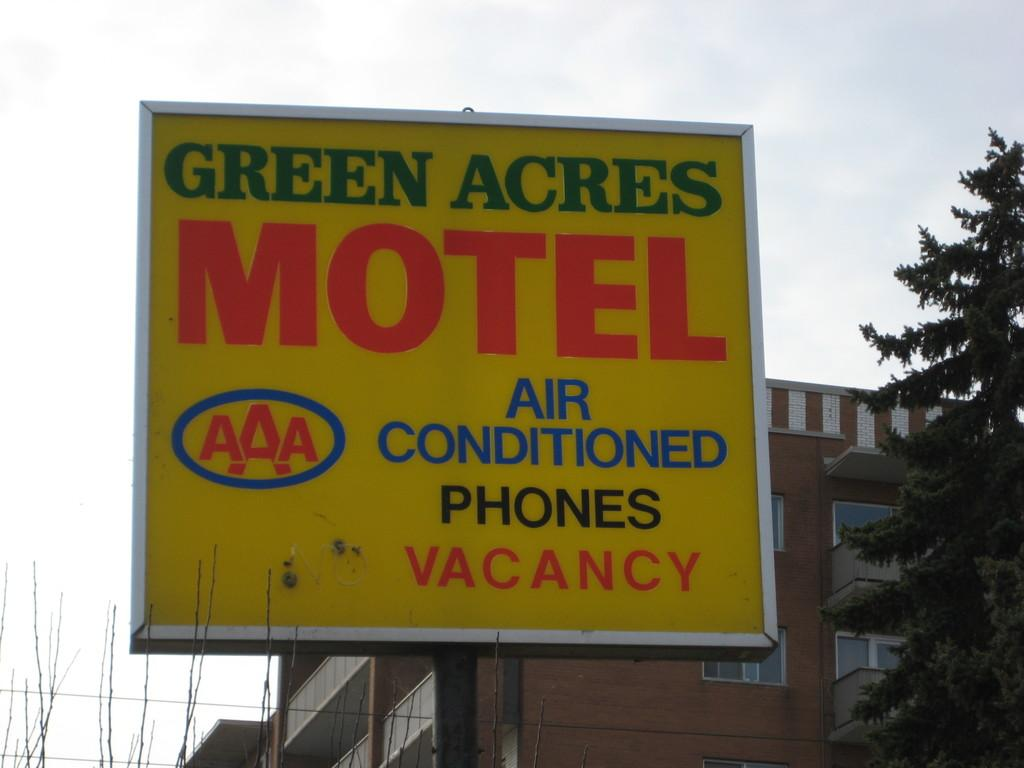<image>
Offer a succinct explanation of the picture presented. Its good to know the Green Acres Motel has air conditioning. 